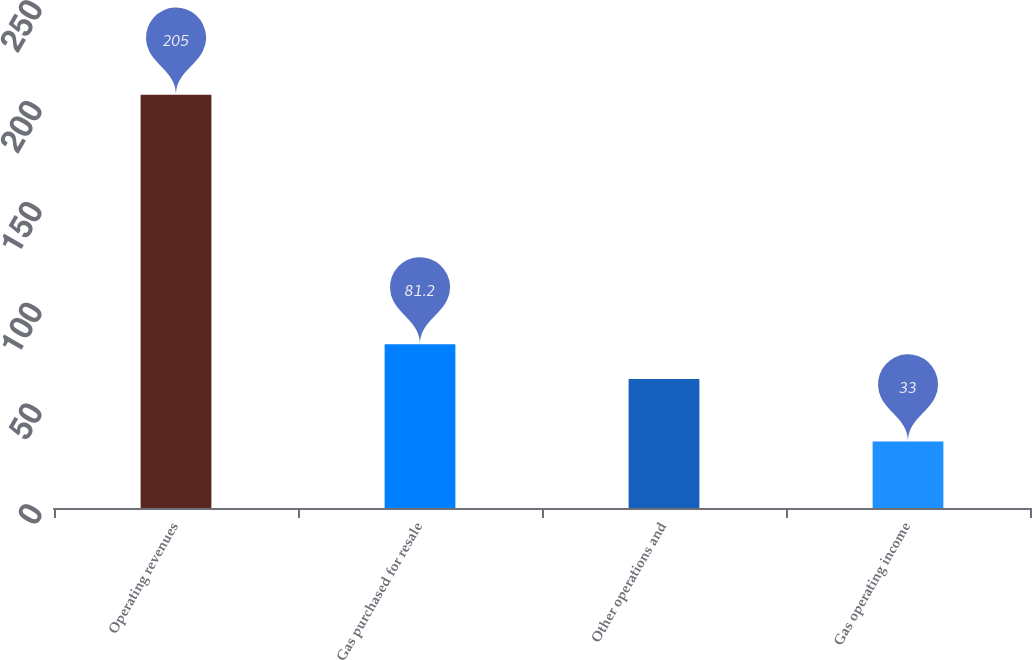<chart> <loc_0><loc_0><loc_500><loc_500><bar_chart><fcel>Operating revenues<fcel>Gas purchased for resale<fcel>Other operations and<fcel>Gas operating income<nl><fcel>205<fcel>81.2<fcel>64<fcel>33<nl></chart> 